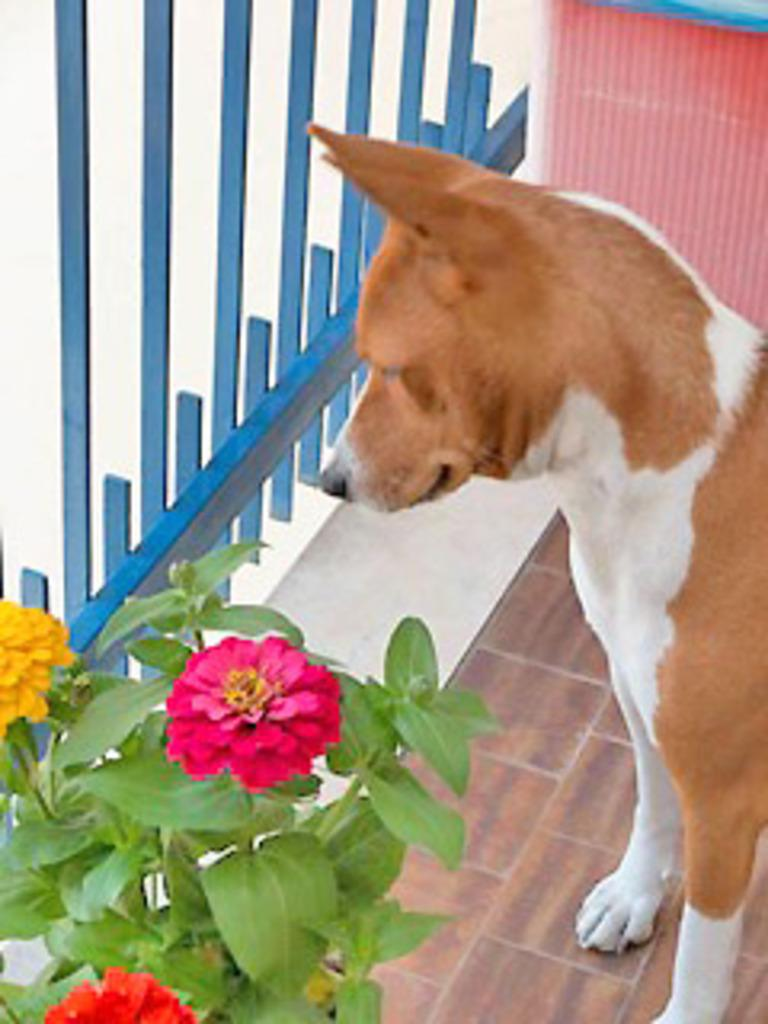What animal can be seen standing on the floor in the image? There is a dog standing on the floor in the image. What type of plant is visible in the image? There is a flower plant in the left side bottom corner of the image. What can be seen in the background of the image? There is a wall and a grill in the background of the image. What type of hill is depicted in the image? There is no hill present in the image. 